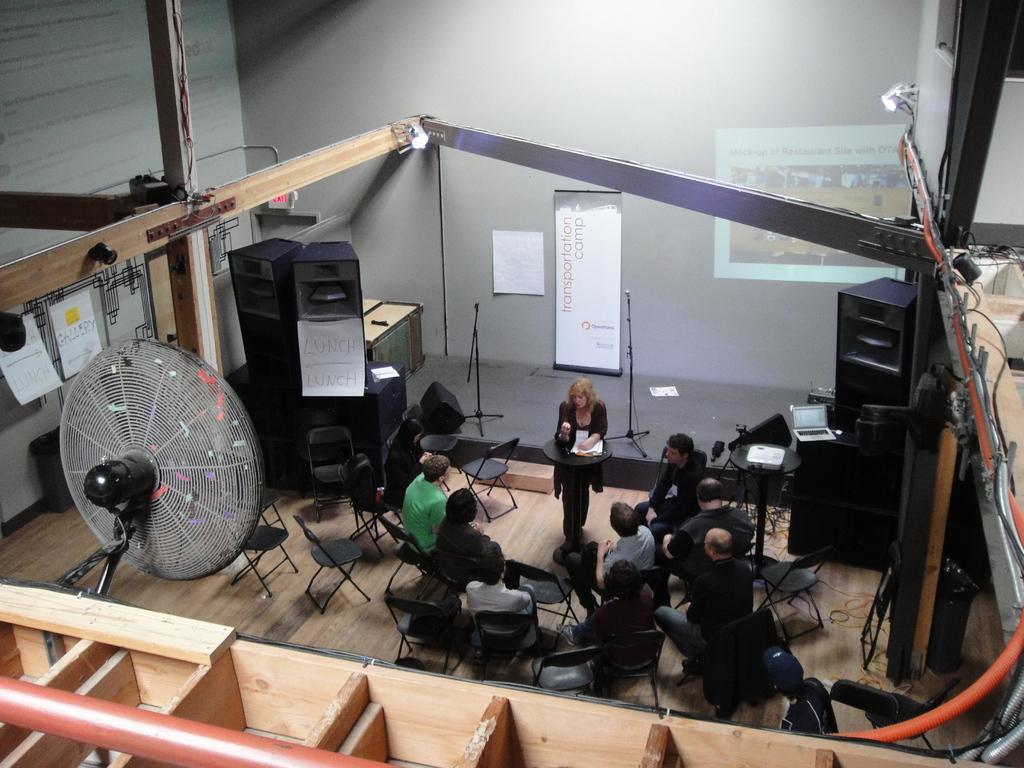Could you give a brief overview of what you see in this image? In this picture we can see a group of people sitting on chairs and a woman standing at a stand, fan, speakers, posters, banner, screen and in the background we can see the wall. 